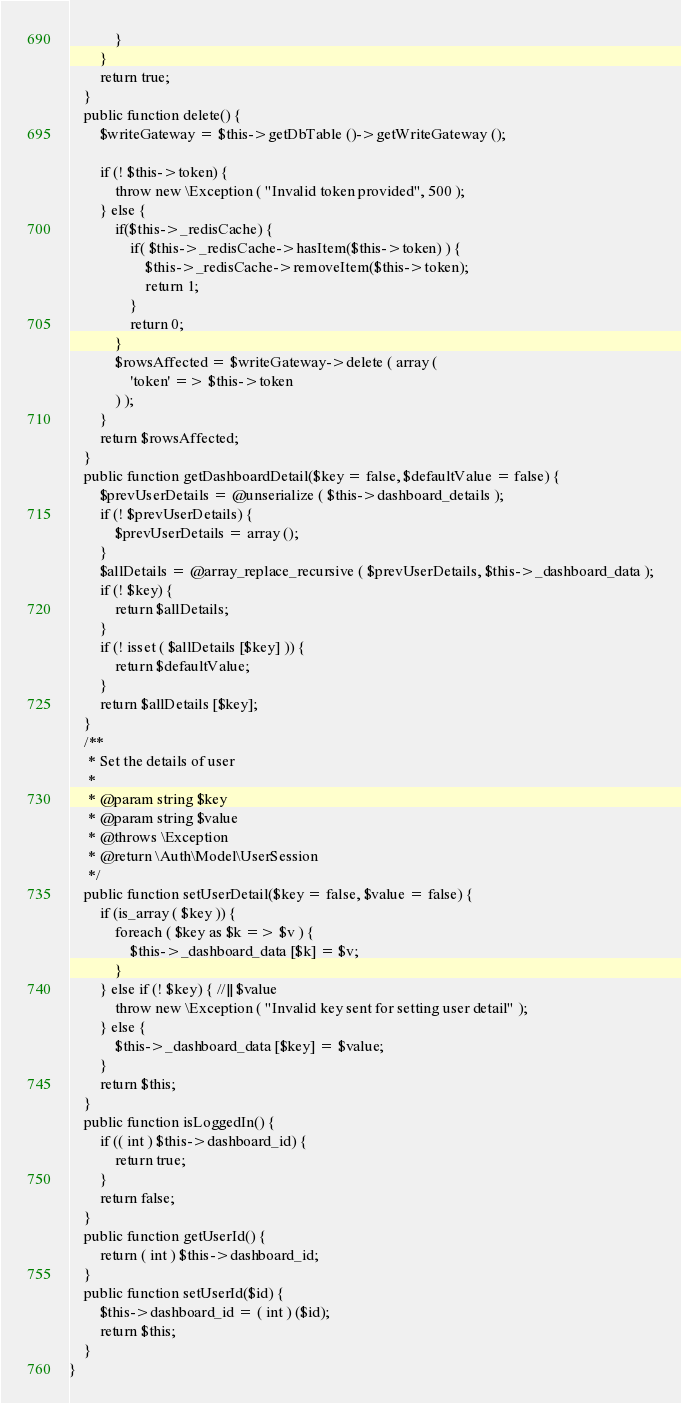<code> <loc_0><loc_0><loc_500><loc_500><_PHP_>			}
		}
		return true;
	}
	public function delete() {
		$writeGateway = $this->getDbTable ()->getWriteGateway ();

		if (! $this->token) {
			throw new \Exception ( "Invalid token provided", 500 );
		} else {
			if($this->_redisCache) {
				if( $this->_redisCache->hasItem($this->token) ) {
					$this->_redisCache->removeItem($this->token);
					return 1;
				}
				return 0;
			}
			$rowsAffected = $writeGateway->delete ( array (
				'token' => $this->token
			) );
		}
		return $rowsAffected;
	}
	public function getDashboardDetail($key = false, $defaultValue = false) {
		$prevUserDetails = @unserialize ( $this->dashboard_details );
		if (! $prevUserDetails) {
			$prevUserDetails = array ();
		}
		$allDetails = @array_replace_recursive ( $prevUserDetails, $this->_dashboard_data );
		if (! $key) {
			return $allDetails;
		}
		if (! isset ( $allDetails [$key] )) {
			return $defaultValue;
		}
		return $allDetails [$key];
	}
	/**
	 * Set the details of user
	 *
	 * @param string $key
	 * @param string $value
	 * @throws \Exception
	 * @return \Auth\Model\UserSession
	 */
	public function setUserDetail($key = false, $value = false) {
		if (is_array ( $key )) {
			foreach ( $key as $k => $v ) {
				$this->_dashboard_data [$k] = $v;
			}
		} else if (! $key) { //|| $value
			throw new \Exception ( "Invalid key sent for setting user detail" );
		} else {
			$this->_dashboard_data [$key] = $value;
		}
		return $this;
	}
	public function isLoggedIn() {
		if (( int ) $this->dashboard_id) {
			return true;
		}
		return false;
	}
	public function getUserId() {
		return ( int ) $this->dashboard_id;
	}
	public function setUserId($id) {
		$this->dashboard_id = ( int ) ($id);
		return $this;
	}   
}</code> 